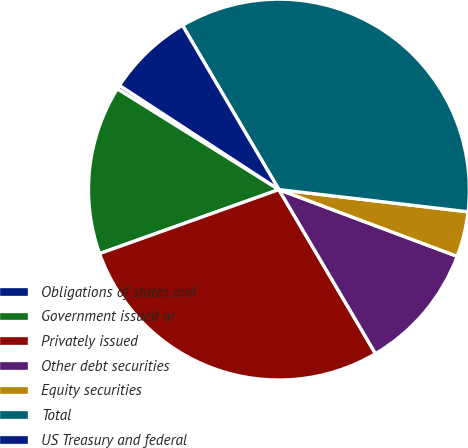Convert chart to OTSL. <chart><loc_0><loc_0><loc_500><loc_500><pie_chart><fcel>Obligations of states and<fcel>Government issued or<fcel>Privately issued<fcel>Other debt securities<fcel>Equity securities<fcel>Total<fcel>US Treasury and federal<nl><fcel>0.34%<fcel>14.33%<fcel>28.01%<fcel>10.83%<fcel>3.84%<fcel>35.31%<fcel>7.34%<nl></chart> 